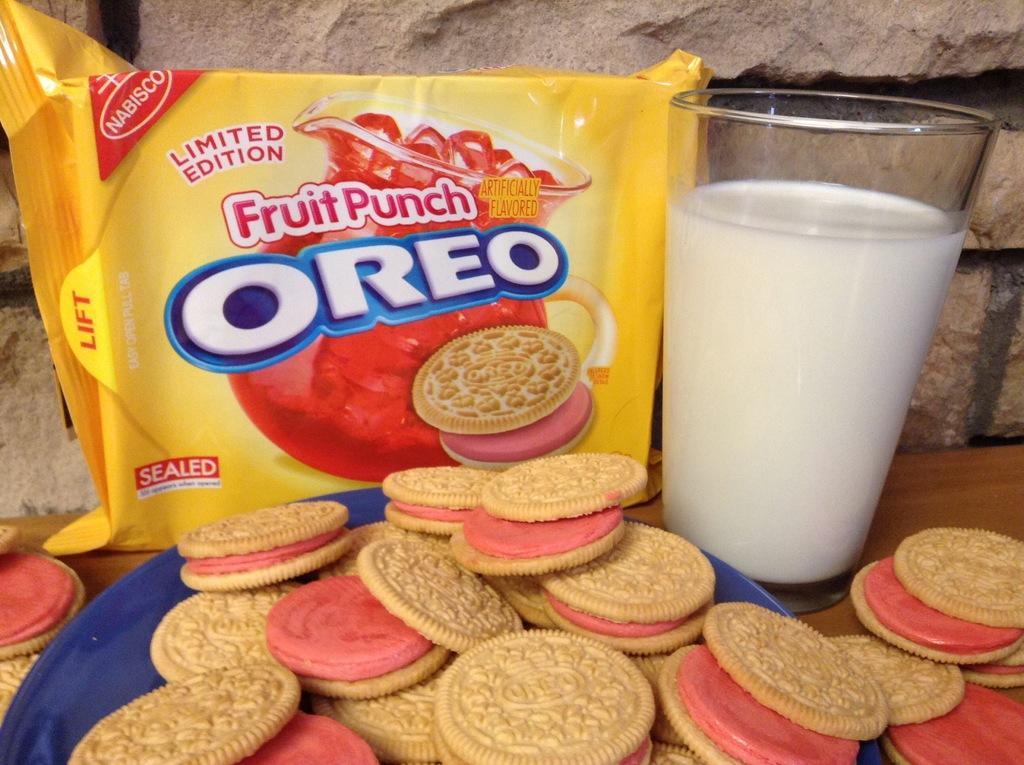Describe this image in one or two sentences. It is a closed picture of a Oreo biscuit packet and a glass of milk and also biscuits placed in a blue color plate and these items are placed on a wooden surface. 